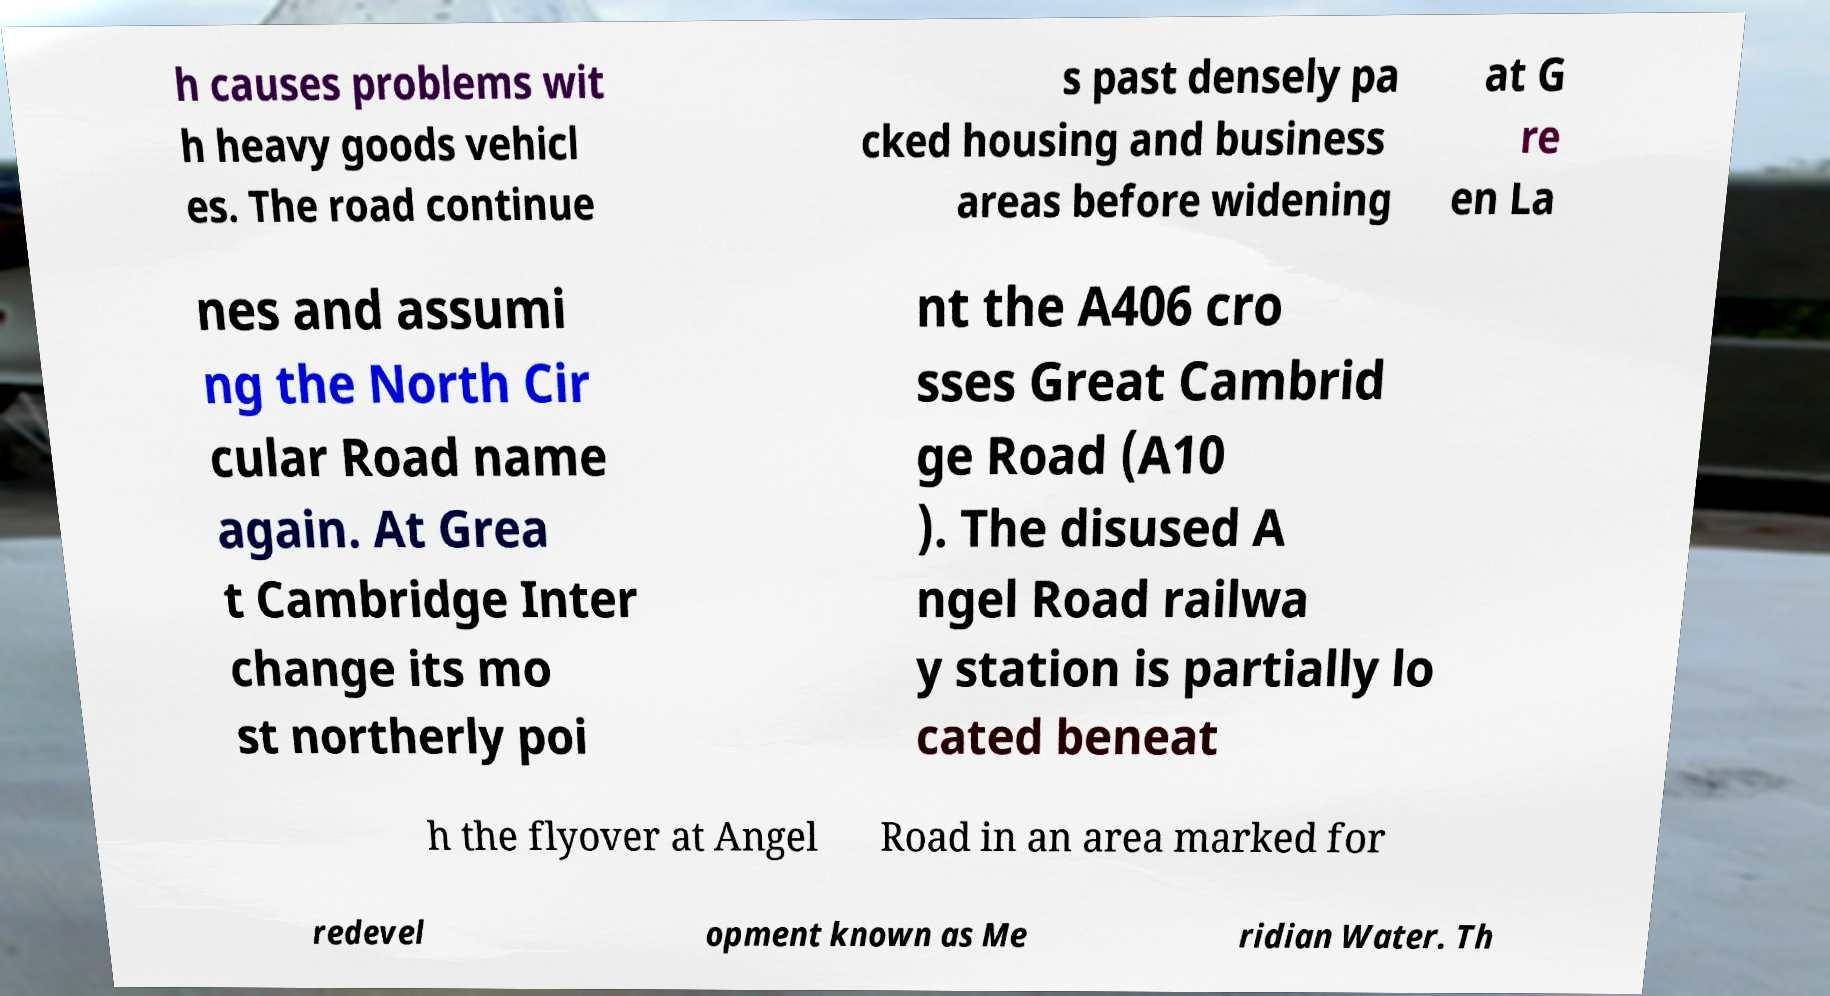Please identify and transcribe the text found in this image. h causes problems wit h heavy goods vehicl es. The road continue s past densely pa cked housing and business areas before widening at G re en La nes and assumi ng the North Cir cular Road name again. At Grea t Cambridge Inter change its mo st northerly poi nt the A406 cro sses Great Cambrid ge Road (A10 ). The disused A ngel Road railwa y station is partially lo cated beneat h the flyover at Angel Road in an area marked for redevel opment known as Me ridian Water. Th 